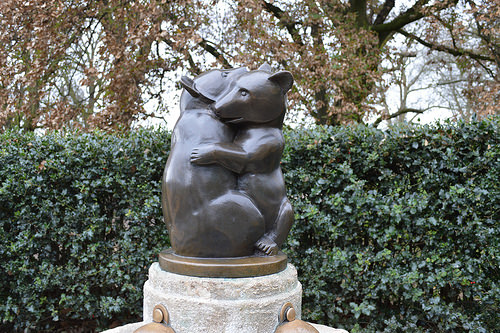<image>
Is the tree behind the statue? Yes. From this viewpoint, the tree is positioned behind the statue, with the statue partially or fully occluding the tree. 